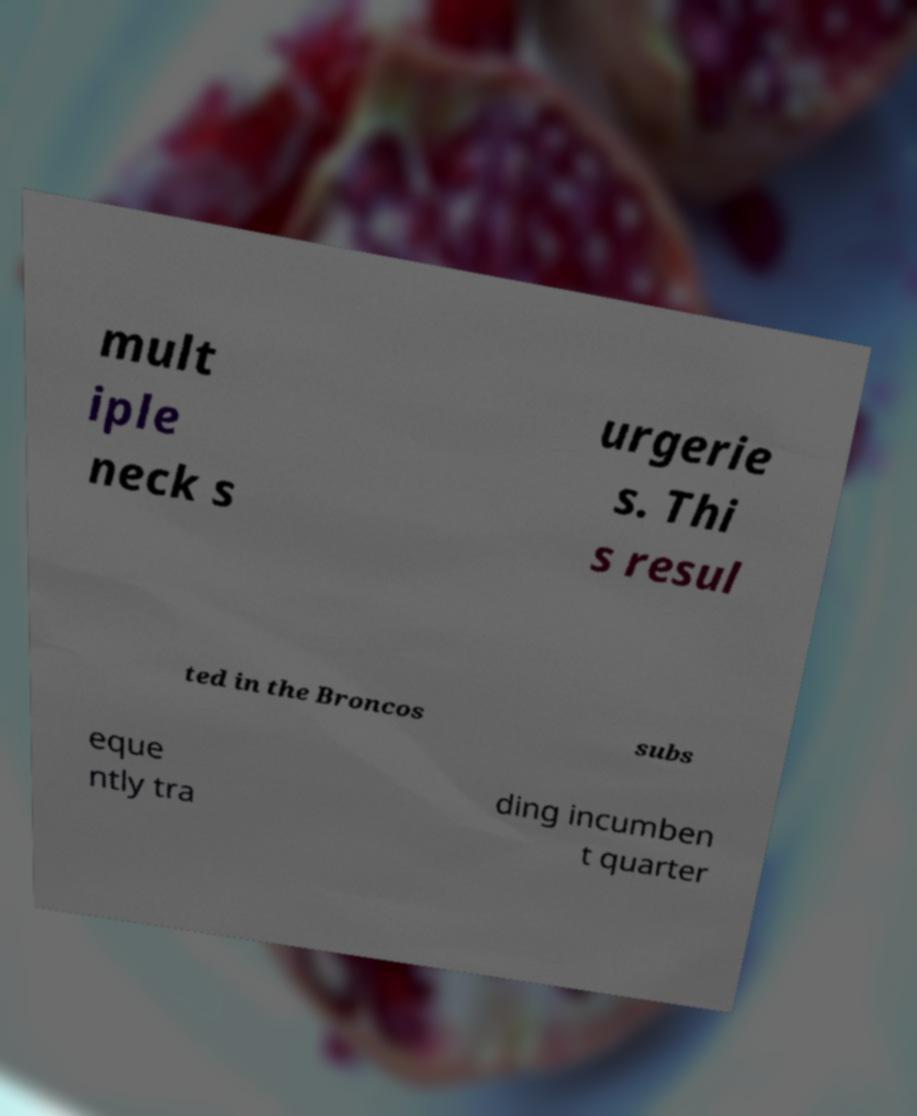Can you accurately transcribe the text from the provided image for me? mult iple neck s urgerie s. Thi s resul ted in the Broncos subs eque ntly tra ding incumben t quarter 